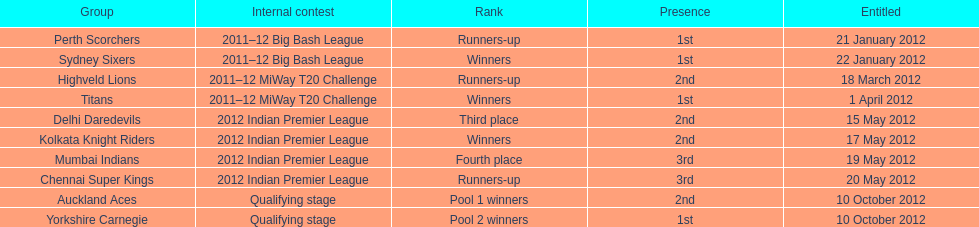What is the total number of teams that qualified? 10. 